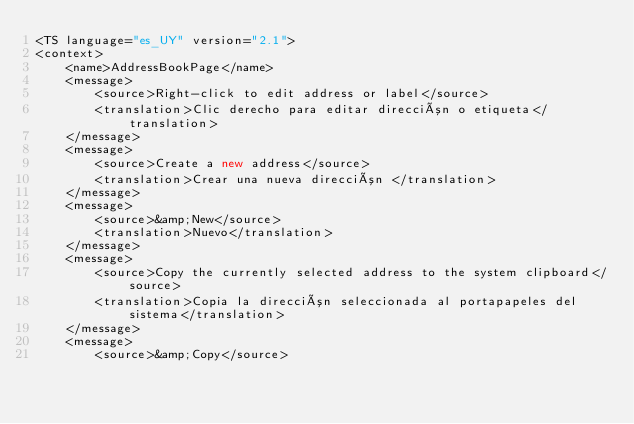Convert code to text. <code><loc_0><loc_0><loc_500><loc_500><_TypeScript_><TS language="es_UY" version="2.1">
<context>
    <name>AddressBookPage</name>
    <message>
        <source>Right-click to edit address or label</source>
        <translation>Clic derecho para editar dirección o etiqueta</translation>
    </message>
    <message>
        <source>Create a new address</source>
        <translation>Crear una nueva dirección </translation>
    </message>
    <message>
        <source>&amp;New</source>
        <translation>Nuevo</translation>
    </message>
    <message>
        <source>Copy the currently selected address to the system clipboard</source>
        <translation>Copia la dirección seleccionada al portapapeles del sistema</translation>
    </message>
    <message>
        <source>&amp;Copy</source></code> 